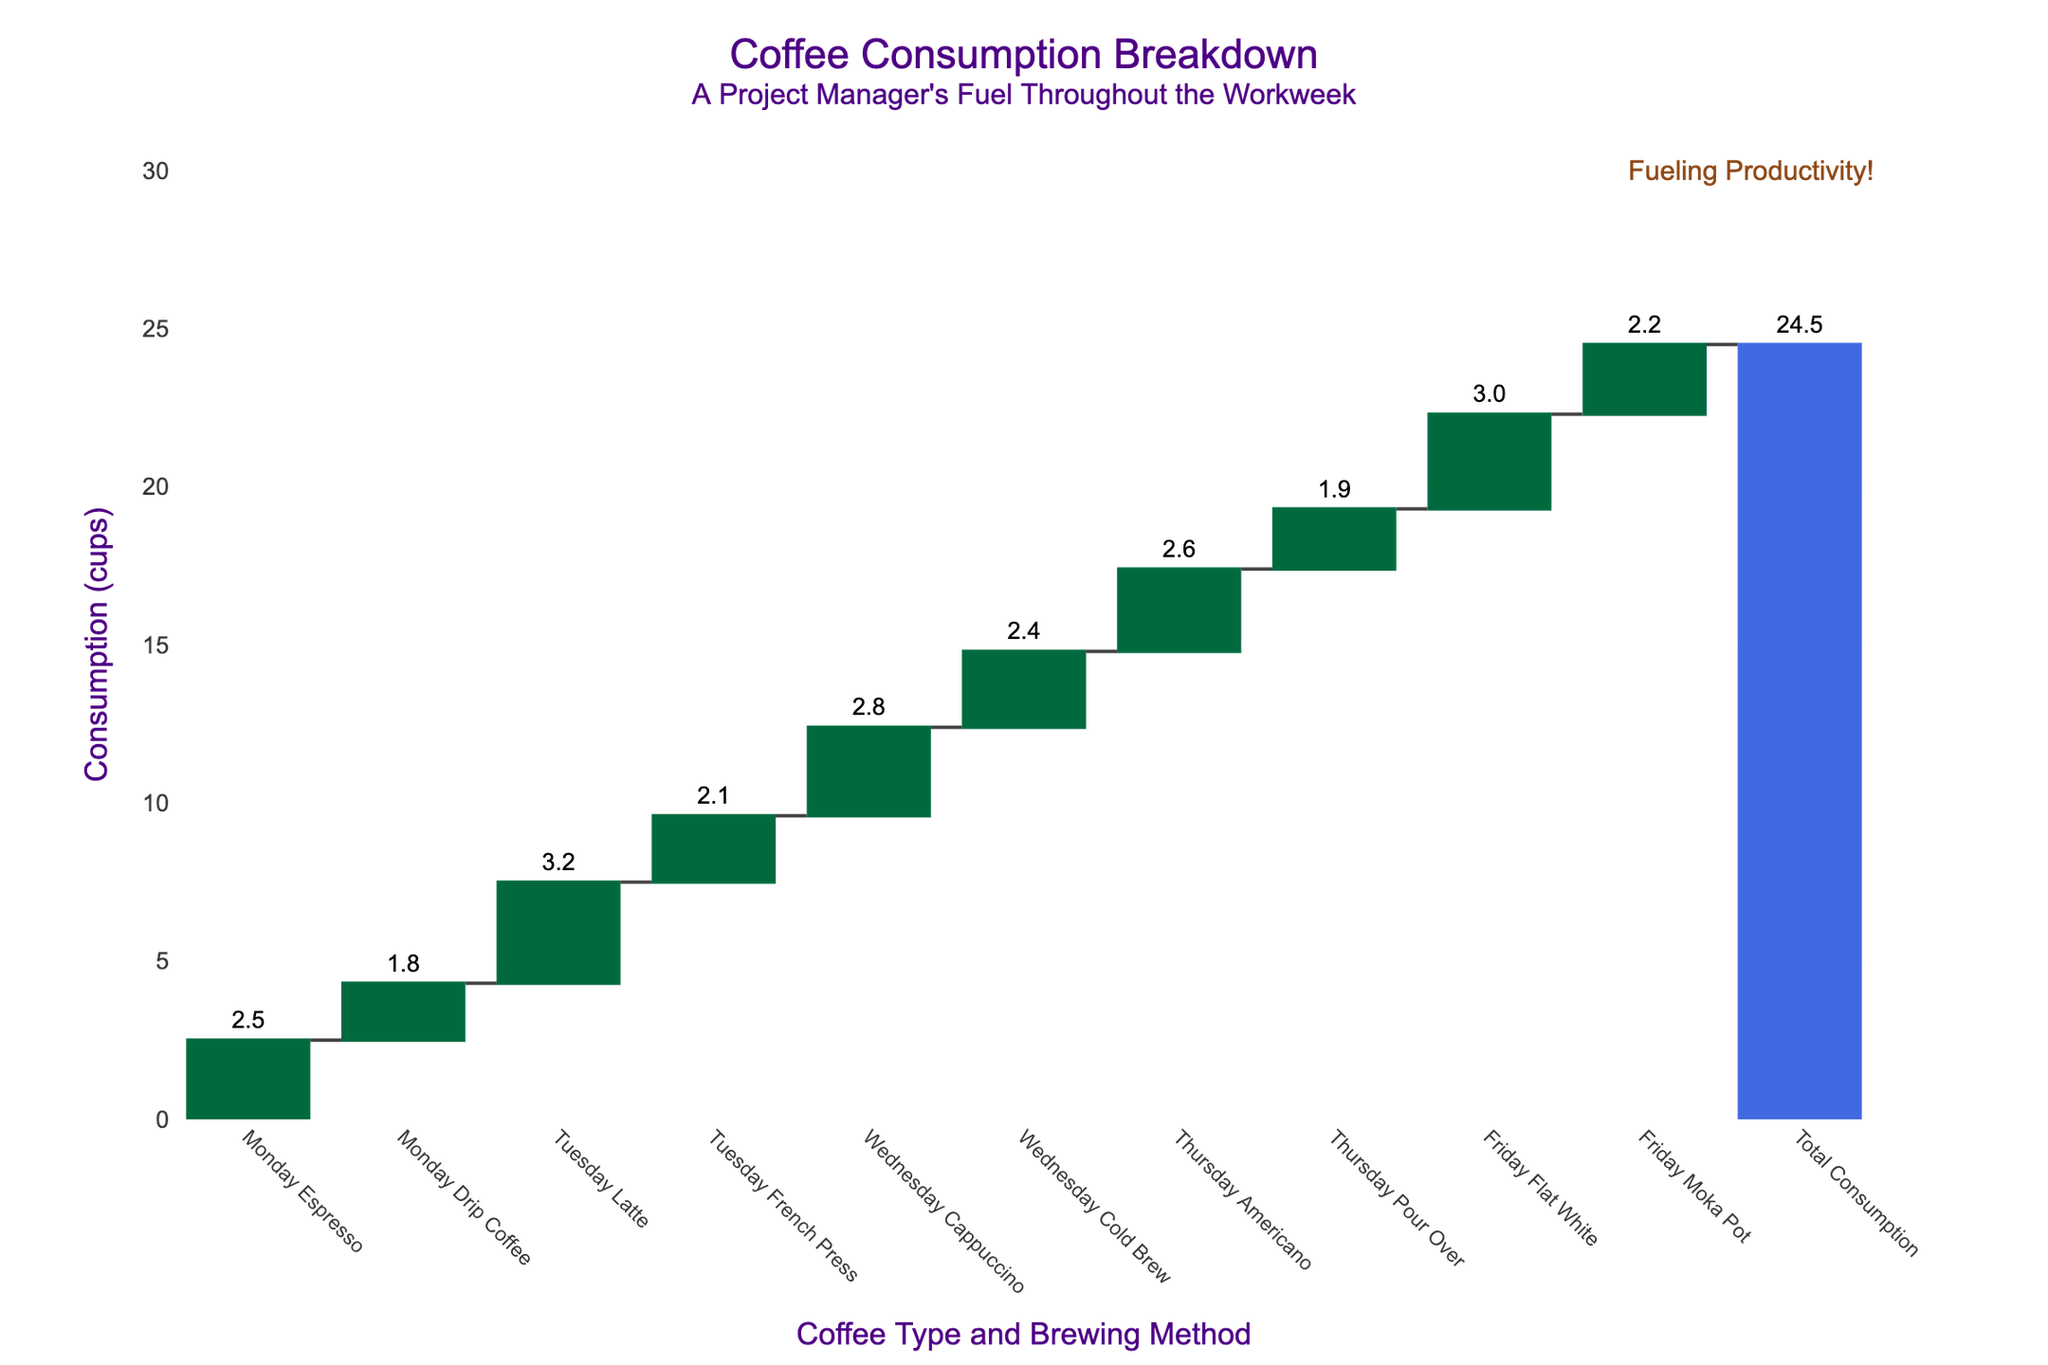What's the title of the chart? The title of the chart is located at the top and reads "Coffee Consumption Breakdown: A Project Manager's Fuel Throughout the Workweek". By reading the text, the title can be easily identified.
Answer: Coffee Consumption Breakdown: A Project Manager's Fuel Throughout the Workweek What is the total coffee consumption for the week? The total coffee consumption is represented by the bar labeled "Total Consumption" at the end of the chart. By viewing the height and label of this bar, we can determine the total.
Answer: 24.5 cups Which day had the highest coffee consumption? To find the highest coffee consumption, we need to compare the heights of the bars for each day. The longest bar belongs to Tuesday with "Tuesday Latte" and "Tuesday French Press". Adding up their values (3.2 + 2.1) shows Tuesday has the highest at 5.3 cups.
Answer: Tuesday How much more coffee was consumed on Tuesday compared to Wednesday? We need the total coffee consumption for Tuesday and Wednesday. By summing the values for Tuesday (3.2 + 2.1 = 5.3 cups) and Wednesday (2.8 + 2.4 = 5.2 cups), and then finding the difference (5.3 - 5.2), we see Tuesday had 0.1 cups more.
Answer: 0.1 cups What is the total coffee consumption over Wednesday and Thursday? Adding up Wednesday’s consumption (2.8 + 2.4 = 5.2) and Thursday’s consumption (2.6 + 1.9 = 4.5), we see that the total is (5.2 + 4.5).
Answer: 9.7 cups Which type of coffee was consumed the least on any day? To find the least consumed coffee, we compare the values of each individual type. "Thursday Pour Over" with 1.9 cups is the lowest among all.
Answer: Pour Over (1.9 cups) Compare the consumption of "Flat White" on Friday to "Americano" on Thursday. Which one is higher and by how much? By checking the values, "Flat White" on Friday is 3.0 cups, and "Americano" on Thursday is 2.6 cups. Subtracting the two (3.0 - 2.6), "Flat White" has 0.4 cups more.
Answer: Flat White; 0.4 cups What's the average daily coffee consumption from Monday to Friday? The total weekly consumption is 24.5 cups. Dividing this by 5 (days of the week), the average daily consumption is calculated (24.5 / 5).
Answer: 4.9 cups What are the components contributing to the coffee consumption on Monday? All contributions for Monday are shown by two specific bars: "Monday Espresso" (2.5 cups) and "Monday Drip Coffee" (1.8 cups). Adding these values provides total Monday consumption (2.5 + 1.8).
Answer: Espresso and Drip Coffee; 4.3 cups 